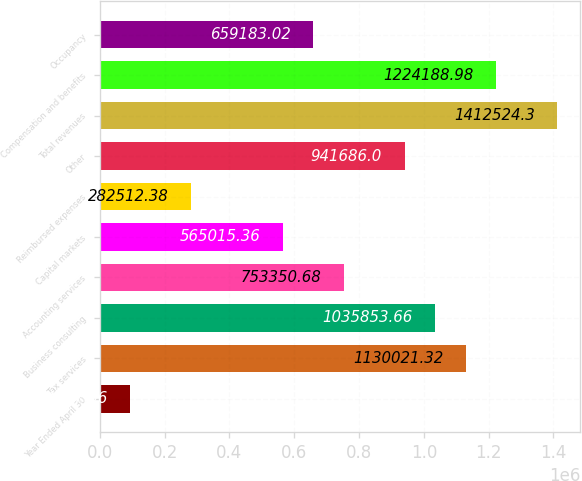Convert chart to OTSL. <chart><loc_0><loc_0><loc_500><loc_500><bar_chart><fcel>Year Ended April 30<fcel>Tax services<fcel>Business consulting<fcel>Accounting services<fcel>Capital markets<fcel>Reimbursed expenses<fcel>Other<fcel>Total revenues<fcel>Compensation and benefits<fcel>Occupancy<nl><fcel>94177.1<fcel>1.13002e+06<fcel>1.03585e+06<fcel>753351<fcel>565015<fcel>282512<fcel>941686<fcel>1.41252e+06<fcel>1.22419e+06<fcel>659183<nl></chart> 